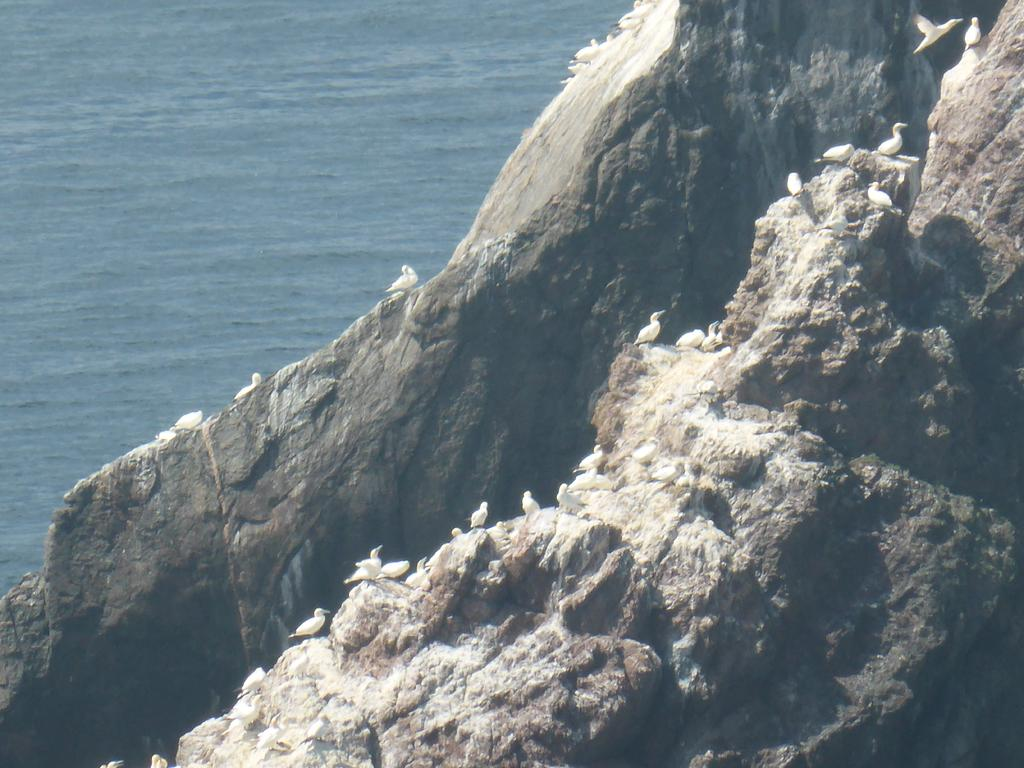What animals can be seen on the rock hills in the image? There are birds on the rock hills in the image. Can you describe the bird in the top right corner of the image? There is a bird flying in the top right corner of the image. What can be seen in the background of the image? There is water visible in the background of the image. What type of fang can be seen in the image? There are no fangs present in the image; it features birds on rock hills and a bird flying in the top right corner. Is there a crib visible in the image? No, there is no crib present in the image. 